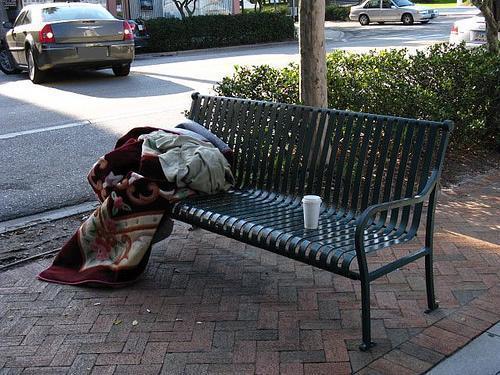How many people are sitting on this bench?
Give a very brief answer. 0. How many benches are there?
Give a very brief answer. 1. How many already fried donuts are there in the image?
Give a very brief answer. 0. 